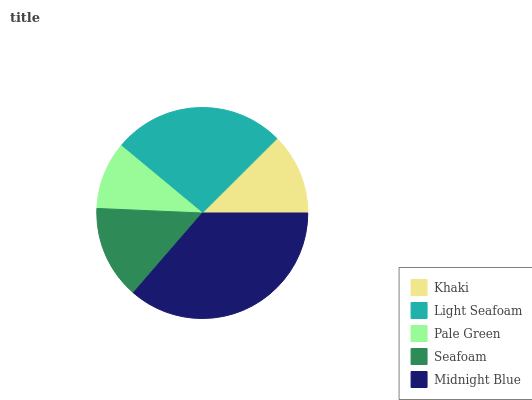Is Pale Green the minimum?
Answer yes or no. Yes. Is Midnight Blue the maximum?
Answer yes or no. Yes. Is Light Seafoam the minimum?
Answer yes or no. No. Is Light Seafoam the maximum?
Answer yes or no. No. Is Light Seafoam greater than Khaki?
Answer yes or no. Yes. Is Khaki less than Light Seafoam?
Answer yes or no. Yes. Is Khaki greater than Light Seafoam?
Answer yes or no. No. Is Light Seafoam less than Khaki?
Answer yes or no. No. Is Seafoam the high median?
Answer yes or no. Yes. Is Seafoam the low median?
Answer yes or no. Yes. Is Khaki the high median?
Answer yes or no. No. Is Pale Green the low median?
Answer yes or no. No. 